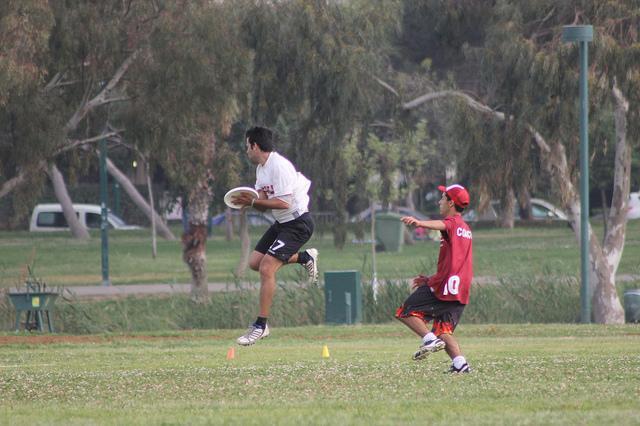How many flags?
Give a very brief answer. 0. How many feet are on the ground?
Give a very brief answer. 1. How many people can you see?
Give a very brief answer. 2. How many bicycles are on the road?
Give a very brief answer. 0. 